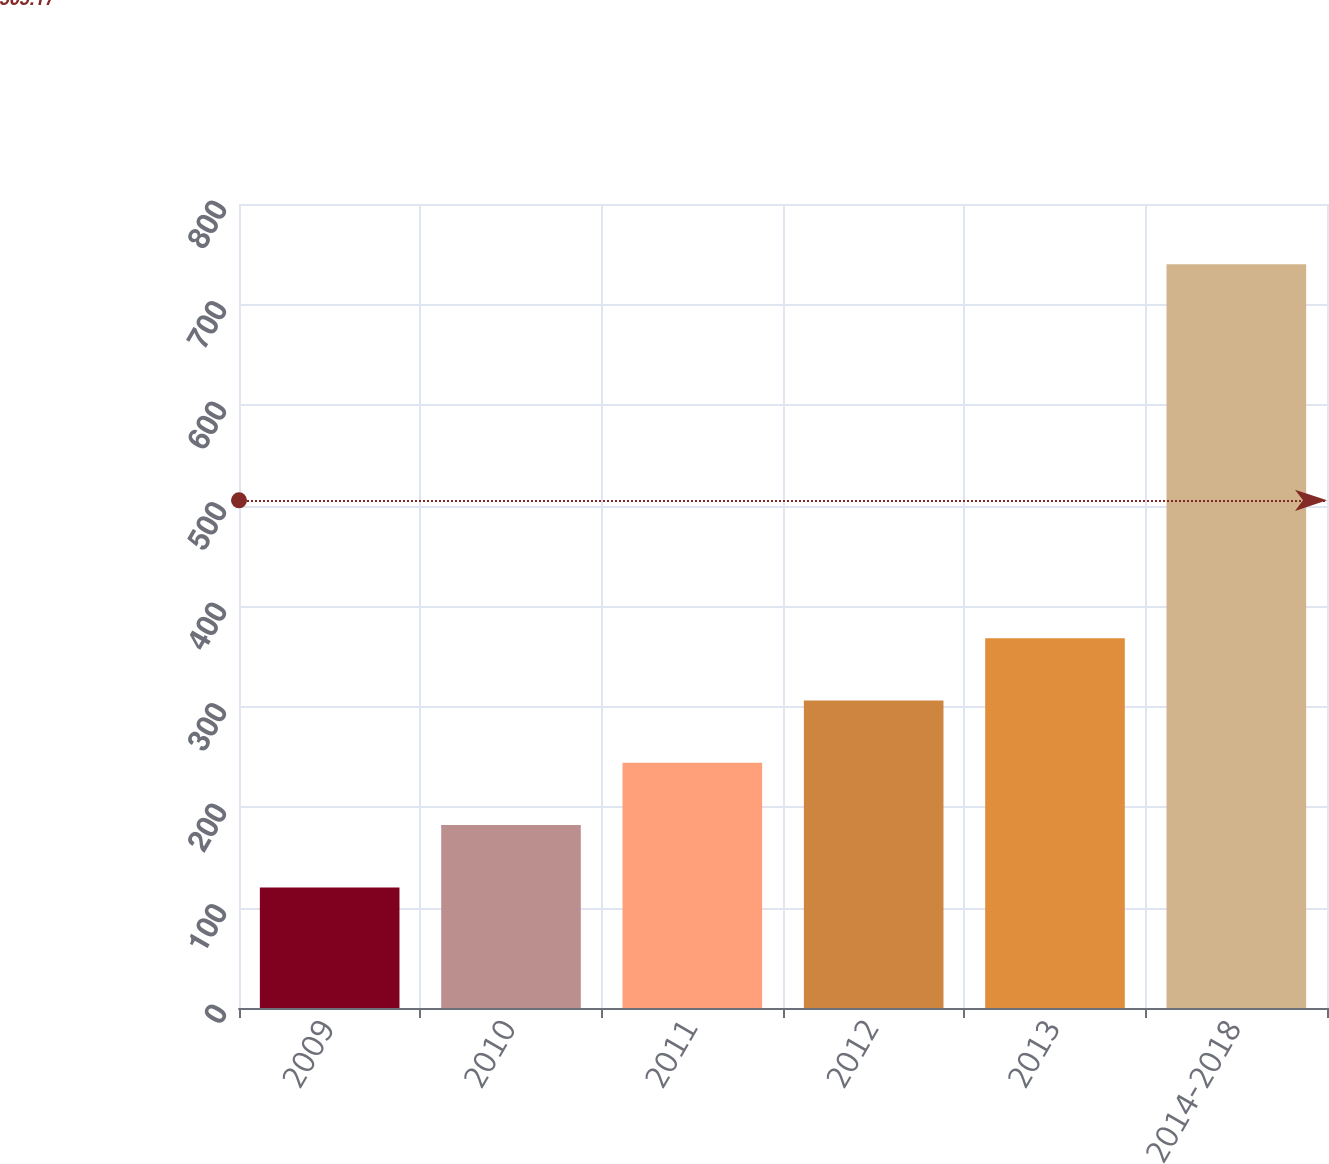Convert chart. <chart><loc_0><loc_0><loc_500><loc_500><bar_chart><fcel>2009<fcel>2010<fcel>2011<fcel>2012<fcel>2013<fcel>2014-2018<nl><fcel>120<fcel>182<fcel>244<fcel>306<fcel>368<fcel>740<nl></chart> 